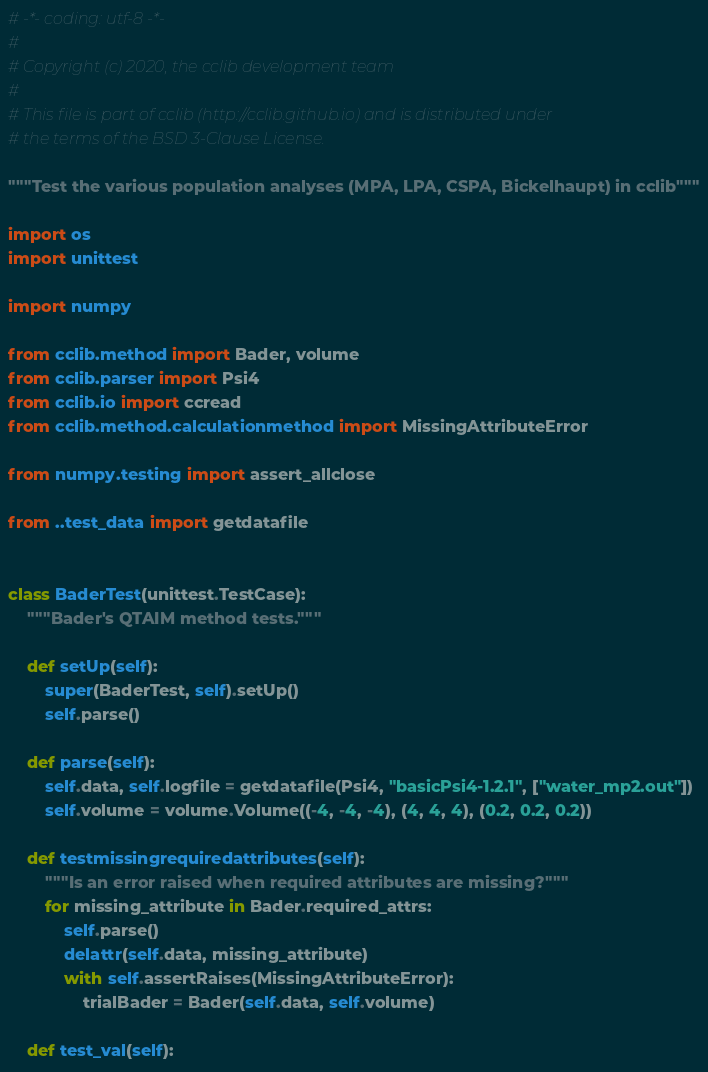<code> <loc_0><loc_0><loc_500><loc_500><_Python_># -*- coding: utf-8 -*-
#
# Copyright (c) 2020, the cclib development team
#
# This file is part of cclib (http://cclib.github.io) and is distributed under
# the terms of the BSD 3-Clause License.

"""Test the various population analyses (MPA, LPA, CSPA, Bickelhaupt) in cclib"""

import os
import unittest

import numpy

from cclib.method import Bader, volume
from cclib.parser import Psi4
from cclib.io import ccread
from cclib.method.calculationmethod import MissingAttributeError

from numpy.testing import assert_allclose

from ..test_data import getdatafile


class BaderTest(unittest.TestCase):
    """Bader's QTAIM method tests."""

    def setUp(self):
        super(BaderTest, self).setUp()
        self.parse()

    def parse(self):
        self.data, self.logfile = getdatafile(Psi4, "basicPsi4-1.2.1", ["water_mp2.out"])
        self.volume = volume.Volume((-4, -4, -4), (4, 4, 4), (0.2, 0.2, 0.2))

    def testmissingrequiredattributes(self):
        """Is an error raised when required attributes are missing?"""
        for missing_attribute in Bader.required_attrs:
            self.parse()
            delattr(self.data, missing_attribute)
            with self.assertRaises(MissingAttributeError):
                trialBader = Bader(self.data, self.volume)

    def test_val(self):</code> 